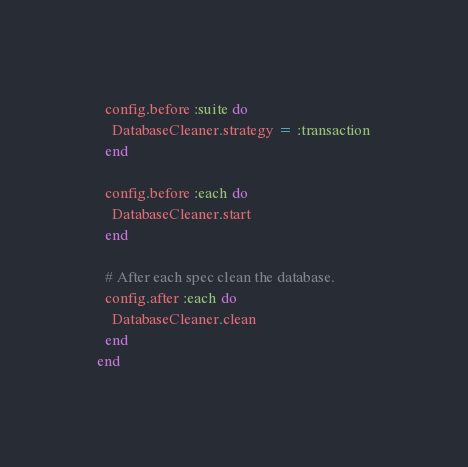<code> <loc_0><loc_0><loc_500><loc_500><_Ruby_>  config.before :suite do
    DatabaseCleaner.strategy = :transaction
  end

  config.before :each do
    DatabaseCleaner.start
  end

  # After each spec clean the database.
  config.after :each do
    DatabaseCleaner.clean
  end
end
</code> 